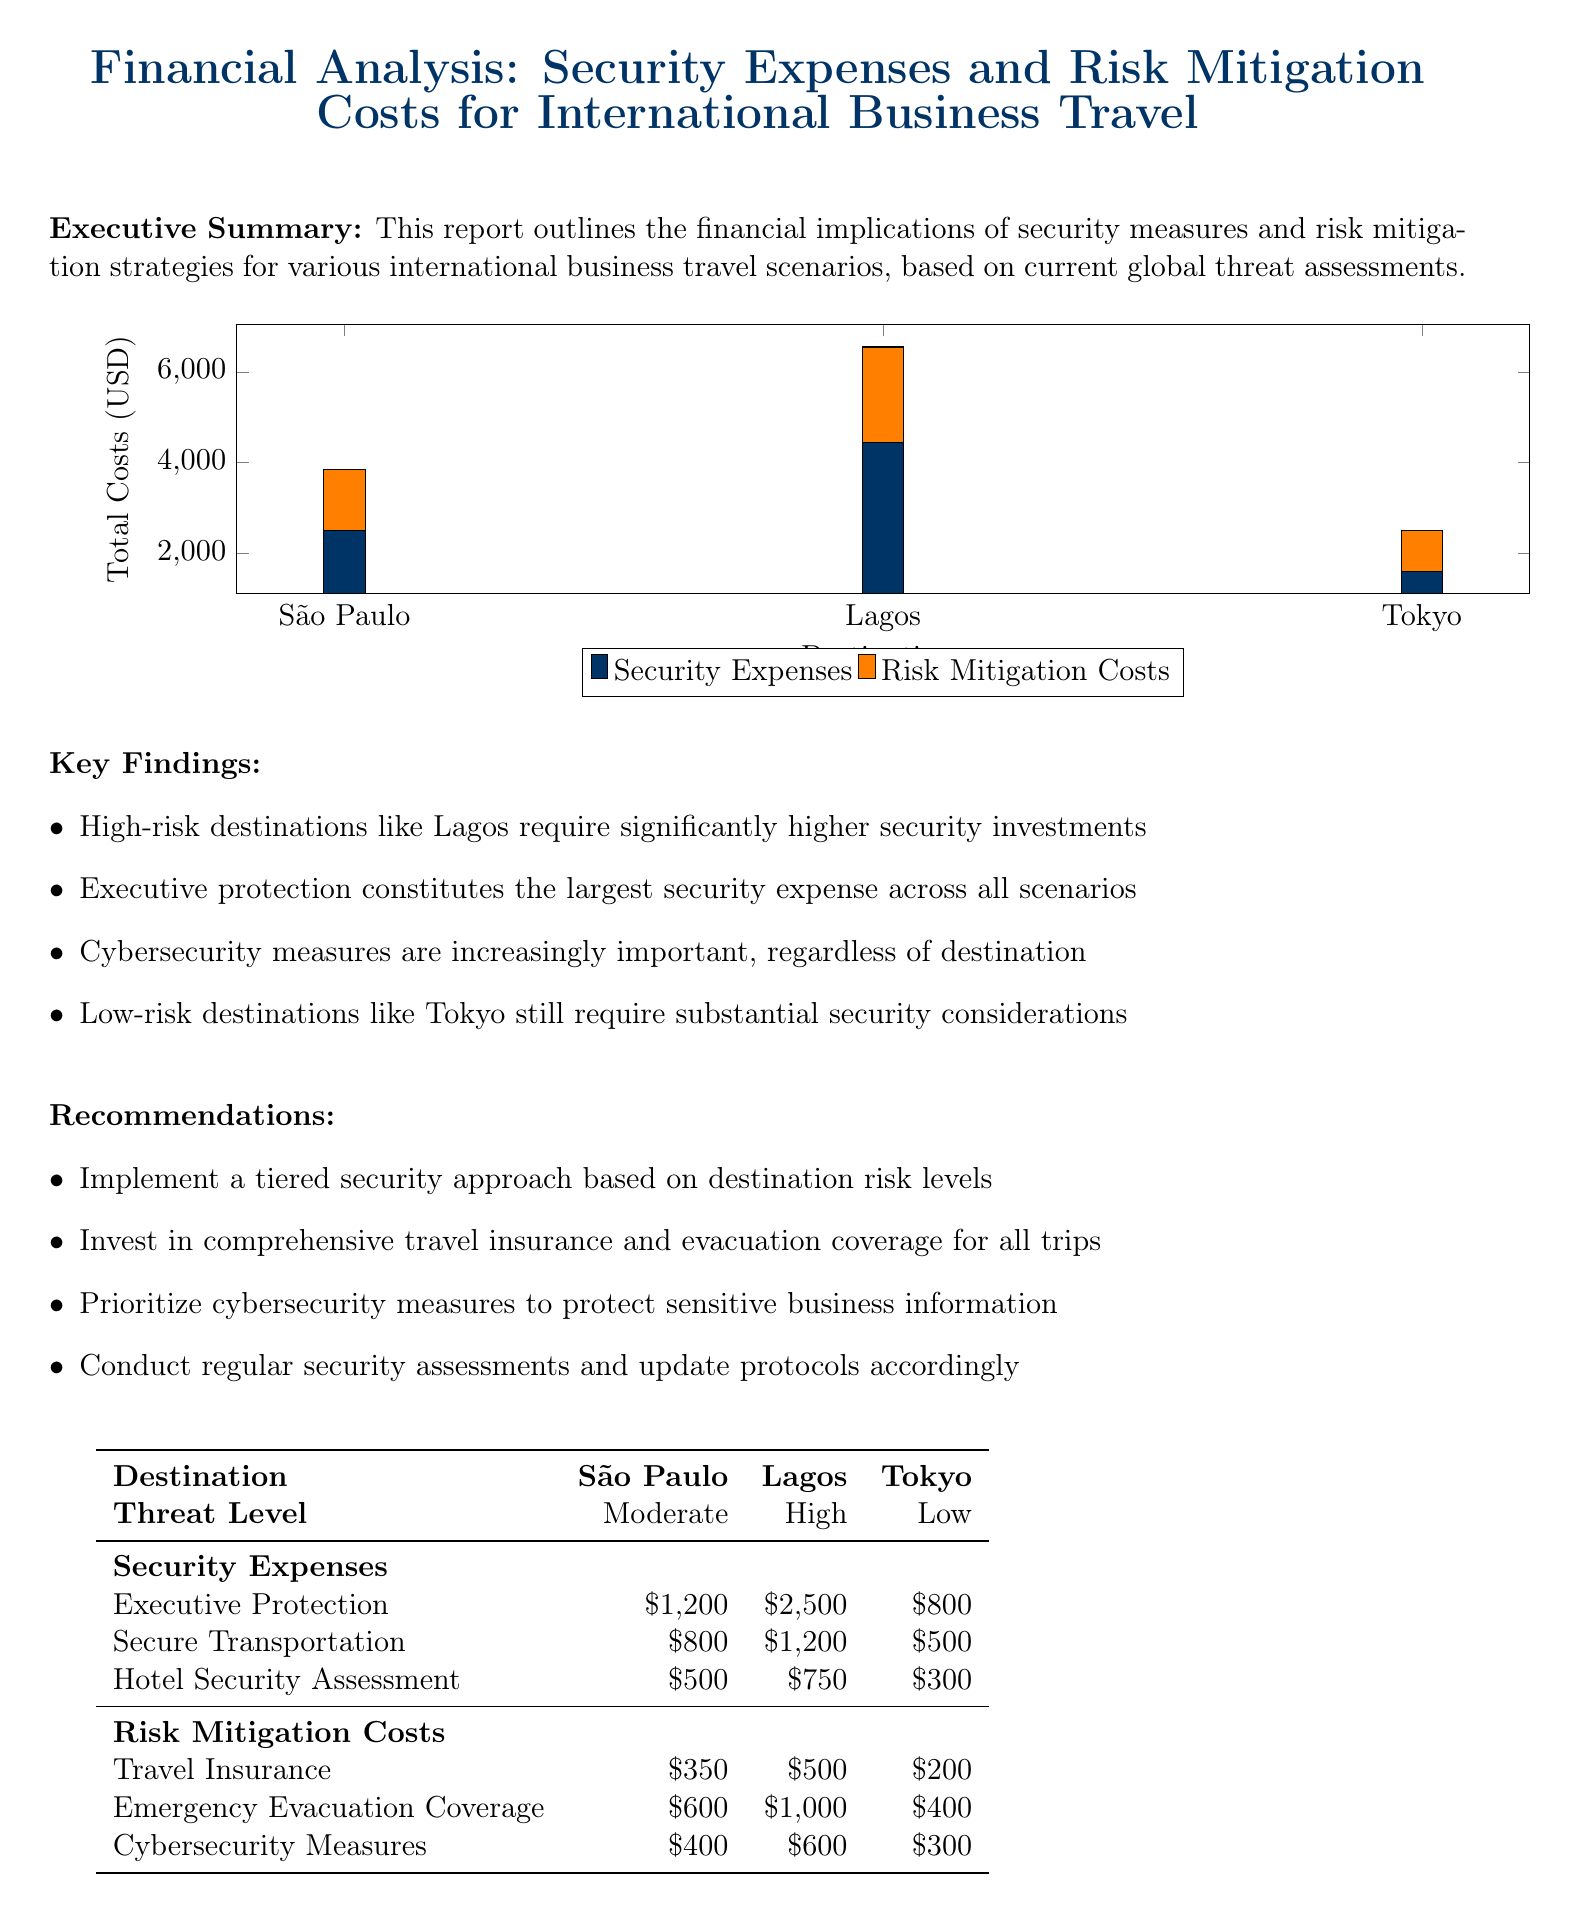What is the total security expenses for Lagos? The security expenses for Lagos are listed as executive protection ($2500) + secure transportation ($1200) + hotel security assessment ($750) = $4450.
Answer: $4450 What is the threat level for Tokyo? The document specifies that the threat level for Tokyo is categorized as Low.
Answer: Low What is the cost of executive protection in São Paulo? The executive protection cost for São Paulo is listed as $1200.
Answer: $1200 What are the total risk mitigation costs for São Paulo? The risk mitigation costs for São Paulo amount to travel insurance ($350) + emergency evacuation coverage ($600) + cybersecurity measures ($400) = $1350.
Answer: $1350 Which destination has the highest risk mitigation costs? By comparing the risk mitigation costs, Lagos has the highest at $2100.
Answer: Lagos What is the average cost of hotel security assessments among the three destinations? The average is calculated as ($500 + $750 + $300) / 3 = $516.67.
Answer: $516.67 What is the main recommendation provided in the report? Among the recommendations, it suggests implementing a tiered security approach based on destination risk levels.
Answer: Tiered security approach What is the total cost for security expenses in Tokyo? The total security expenses in Tokyo are $800 + $500 + $300 = $1600.
Answer: $1600 Which security expense is the largest across all scenarios? The document indicates that executive protection constitutes the largest security expense across all scenarios.
Answer: Executive protection 